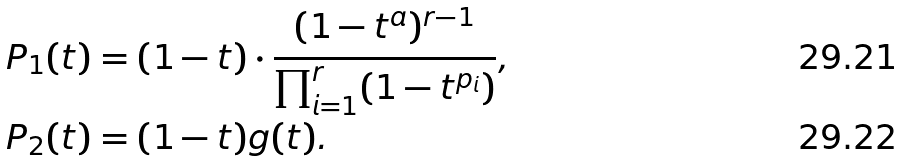<formula> <loc_0><loc_0><loc_500><loc_500>P _ { 1 } ( t ) & = ( 1 - t ) \cdot \frac { ( 1 - t ^ { a } ) ^ { r - 1 } } { \prod _ { i = 1 } ^ { r } ( 1 - t ^ { p _ { i } } ) } , \\ P _ { 2 } ( t ) & = ( 1 - t ) g ( t ) .</formula> 